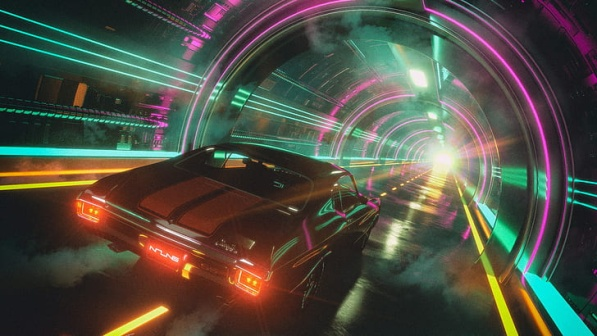How does the color scheme contribute to the mood of the image? The vibrant neon colors, particularly the blues and pinks arching over the tunnel, coupled with the car's red taillights and the glowing white light, create a dynamic and visually compelling atmosphere. They evoke a sense of energy and futuristic vibrancy, suggesting not only a physical but also a metaphorical movement towards a high-tech, optimistic future. 